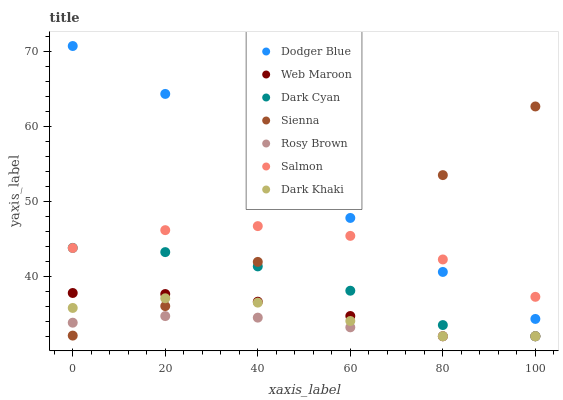Does Rosy Brown have the minimum area under the curve?
Answer yes or no. Yes. Does Dodger Blue have the maximum area under the curve?
Answer yes or no. Yes. Does Salmon have the minimum area under the curve?
Answer yes or no. No. Does Salmon have the maximum area under the curve?
Answer yes or no. No. Is Rosy Brown the smoothest?
Answer yes or no. Yes. Is Sienna the roughest?
Answer yes or no. Yes. Is Salmon the smoothest?
Answer yes or no. No. Is Salmon the roughest?
Answer yes or no. No. Does Dark Khaki have the lowest value?
Answer yes or no. Yes. Does Salmon have the lowest value?
Answer yes or no. No. Does Dodger Blue have the highest value?
Answer yes or no. Yes. Does Salmon have the highest value?
Answer yes or no. No. Is Rosy Brown less than Dodger Blue?
Answer yes or no. Yes. Is Dodger Blue greater than Dark Khaki?
Answer yes or no. Yes. Does Web Maroon intersect Dark Cyan?
Answer yes or no. Yes. Is Web Maroon less than Dark Cyan?
Answer yes or no. No. Is Web Maroon greater than Dark Cyan?
Answer yes or no. No. Does Rosy Brown intersect Dodger Blue?
Answer yes or no. No. 